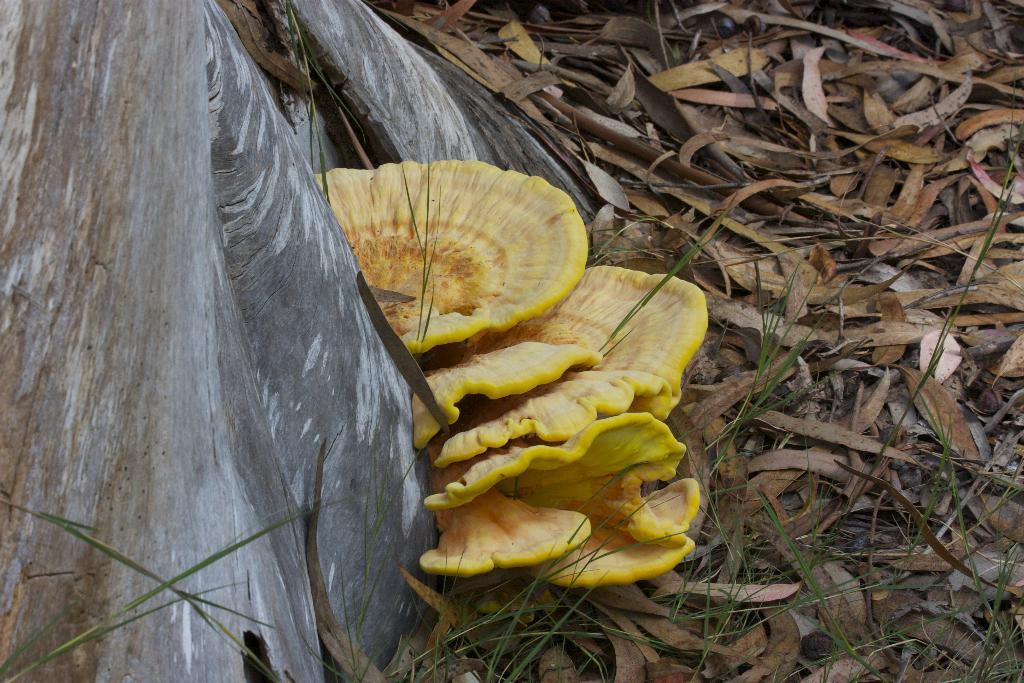How would you summarize this image in a sentence or two? In this image, I can see mushrooms, dried leaves and a tree trunk. 